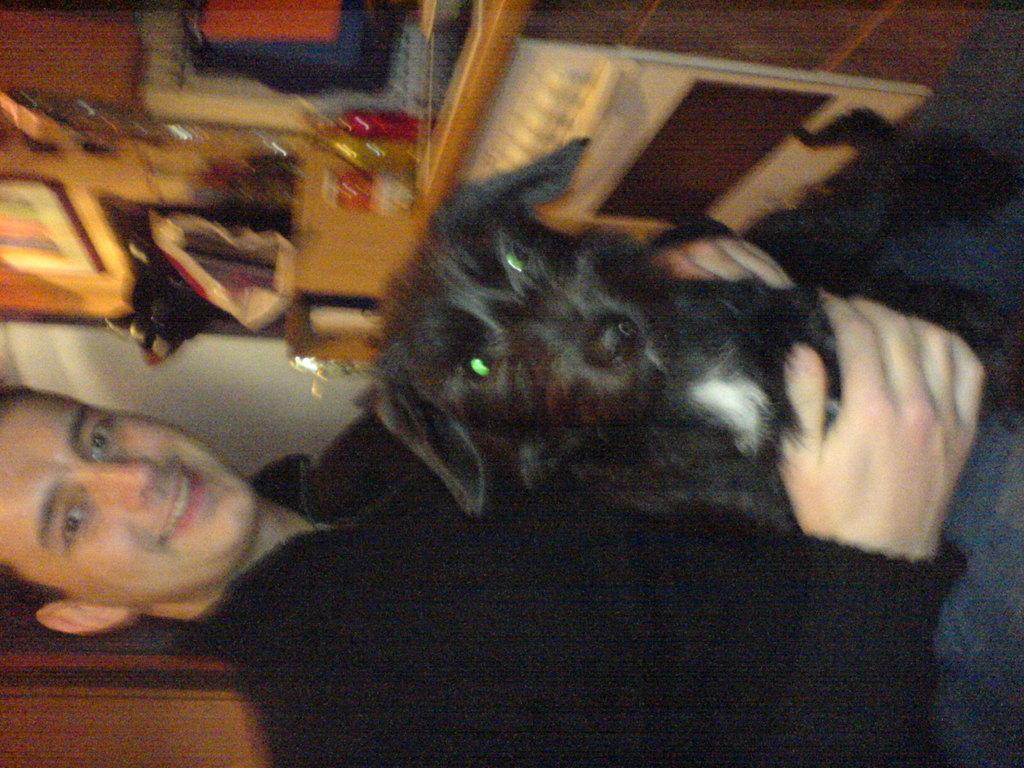Could you give a brief overview of what you see in this image? As we can see in the image, there is a man holding a black color dog. 